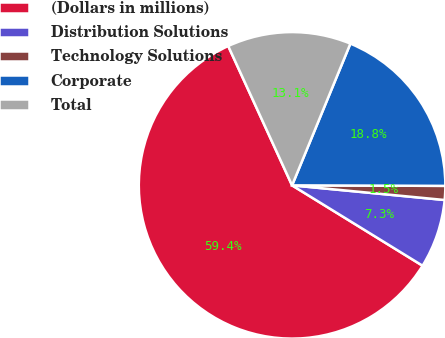<chart> <loc_0><loc_0><loc_500><loc_500><pie_chart><fcel>(Dollars in millions)<fcel>Distribution Solutions<fcel>Technology Solutions<fcel>Corporate<fcel>Total<nl><fcel>59.37%<fcel>7.26%<fcel>1.47%<fcel>18.84%<fcel>13.05%<nl></chart> 